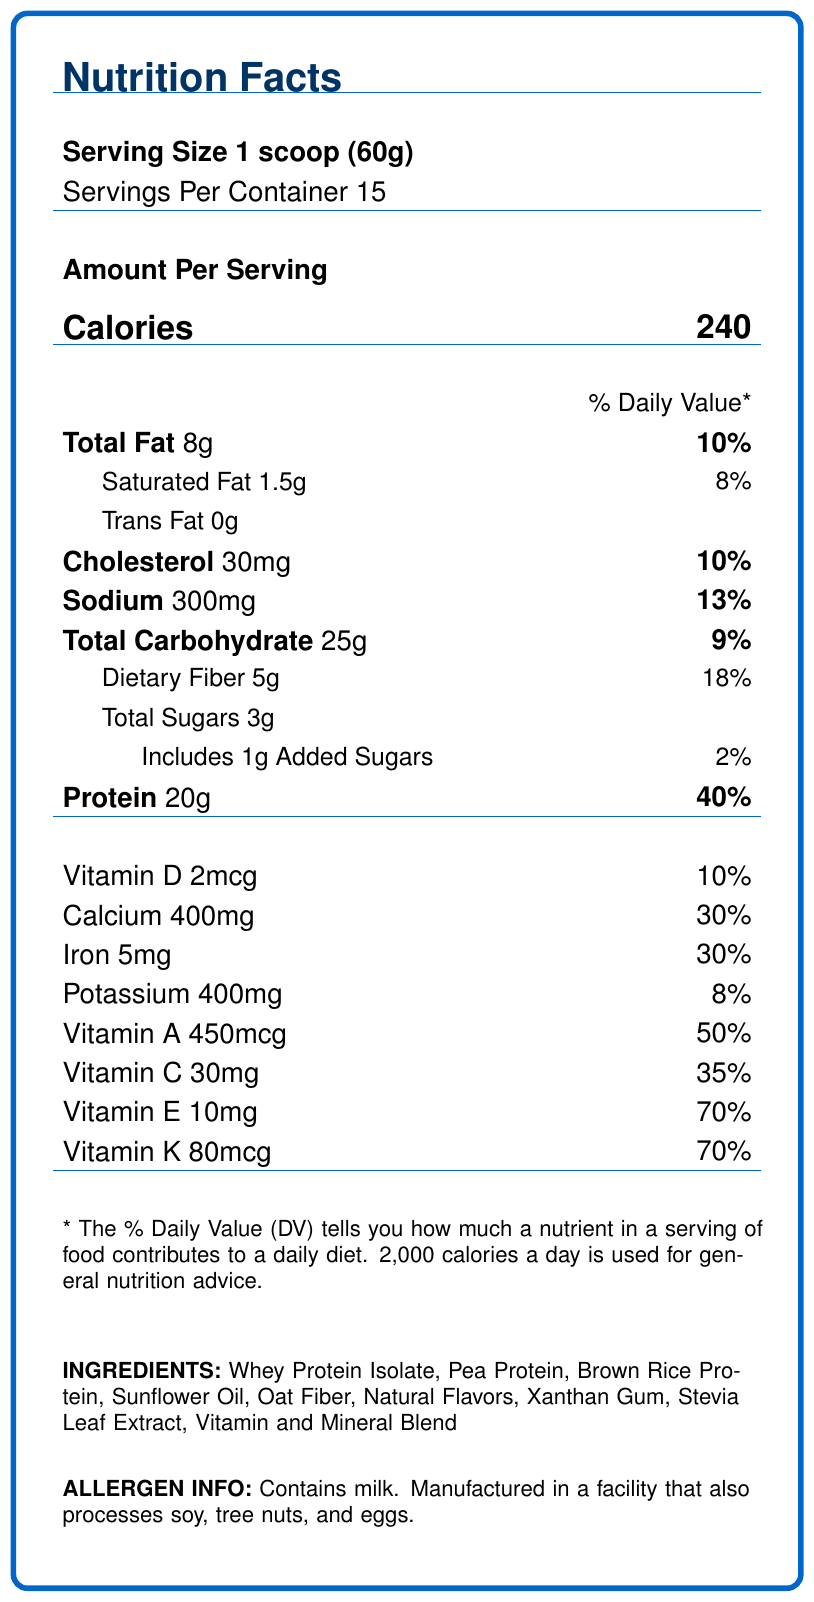what is the serving size? The serving size is explicitly stated near the top of the document under the "Serving Size" section.
Answer: 1 scoop (60g) how many servings are in each container? The number of servings per container is listed immediately below the serving size.
Answer: 15 servings what is the amount of calories per serving? The calorie amount is prominently displayed in large font under "Amount Per Serving."
Answer: 240 calories how much total fat is in one serving? The total fat content per serving is listed next to "Total Fat" under the "Amount Per Serving" section.
Answer: 8g what is the daily value percentage for protein per serving? The daily value percentage for protein is found next to the protein amount in the "Amount Per Serving" section.
Answer: 40% which nutrient has the highest daily value percentage? A. Calcium B. Vitamin A C. Vitamin K D. Protein The daily value percentage for Vitamin K is 70%, which is the highest among the listed nutrients.
Answer: C. Vitamin K how much dietary fiber does each serving contain? A. 5g B. 8g C. 10g D. 15g The dietary fiber content per serving is listed as 5g in the "Amount Per Serving" section.
Answer: A. 5g does the product contain any added sugars? The document shows "Includes 1g Added Sugars," indicating the presence of added sugars.
Answer: Yes summarize the main purpose of the document. The document is a Nutrition Facts Label for a meal replacement shake, offering comprehensive details to help consumers understand the nutritional benefits and contents of the product.
Answer: The document provides detailed nutritional information about the PowerPro Meal Shake, including serving size, calorie content, macronutrient breakdown, vitamins, minerals, ingredients, allergen information, and storage and preparation instructions. does the product contain any trans fat? The "Trans Fat" section of the document clearly indicates "0g," showing there is no trans fat.
Answer: No what are the main protein sources listed in the ingredients? These protein sources are listed in the ingredients section of the document.
Answer: Whey Protein Isolate, Pea Protein, Brown Rice Protein where should you store the product after mixing it? The storage instructions specifically state to "Refrigerate after mixing."
Answer: In the refrigerator what certifications does the PowerPro Meal Shake have? This information is found in the certifications section of the document.
Answer: Non-GMO Project Verified, Informed-Choice Certified what is the recommended mixing instruction for the PowerPro Meal Shake? The preparation instructions part of the document provides this recommendation.
Answer: Mix 1 scoop (60g) with 8-10 oz of cold water or your favorite milk. Shake well and enjoy! is the product suitable for people with nut allergies? The allergen info indicates that the product is manufactured in a facility that processes tree nuts, which might not be suitable for people with nut allergies.
Answer: No how much selenium does each serving of the product contain? The selenium content per serving is listed under "Amount Per Serving" for nutrients.
Answer: 35mcg what is the address of the manufacturer? The document does not provide the address of the manufacturer; it only lists the names of the manufacturer and distributor.
Answer: Cannot be determined 